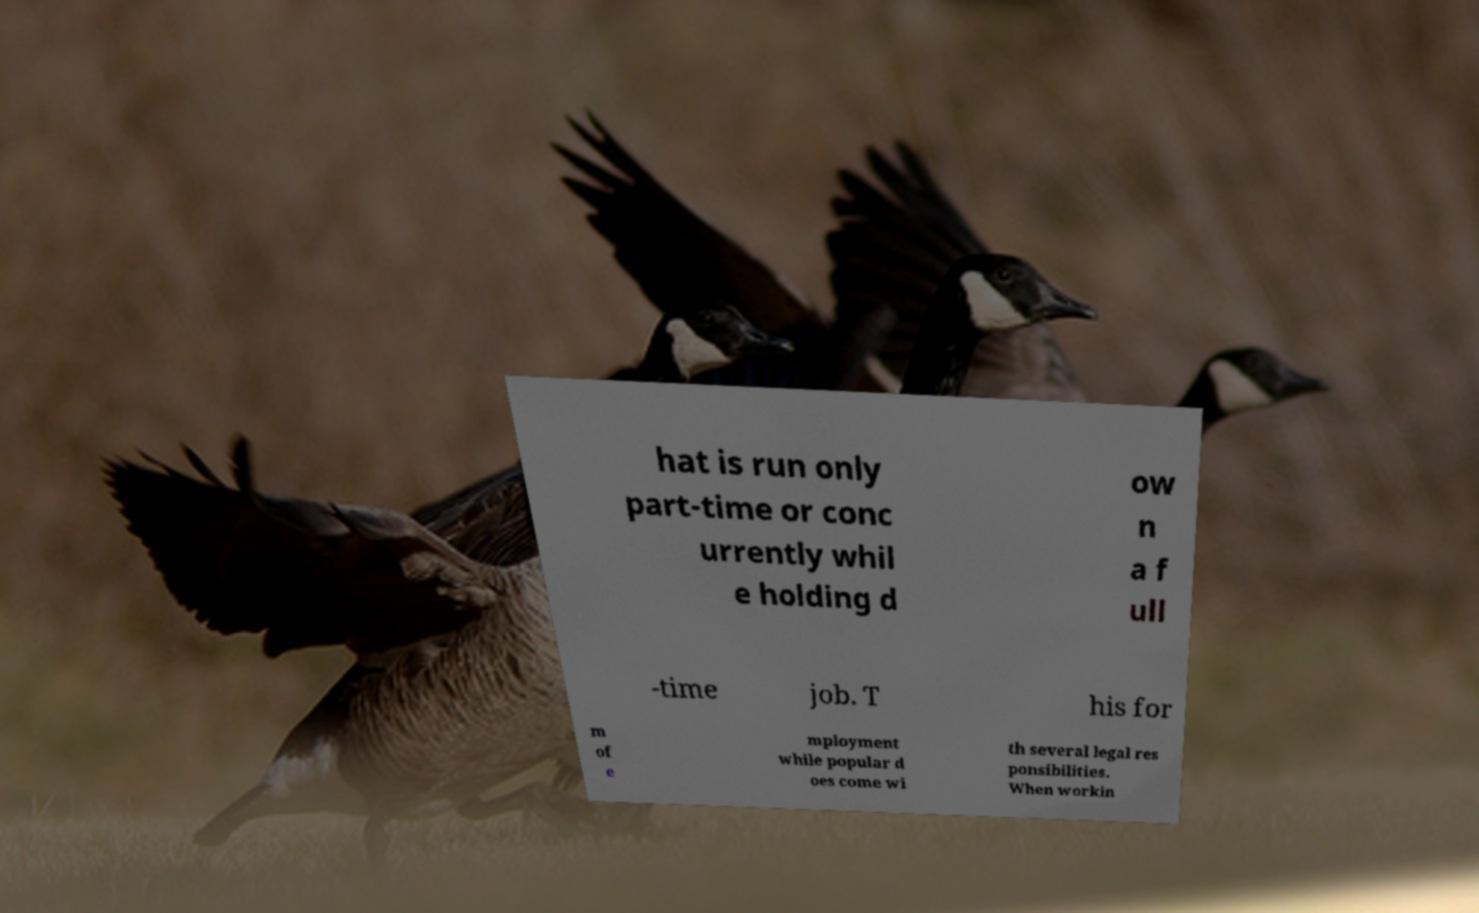I need the written content from this picture converted into text. Can you do that? hat is run only part-time or conc urrently whil e holding d ow n a f ull -time job. T his for m of e mployment while popular d oes come wi th several legal res ponsibilities. When workin 